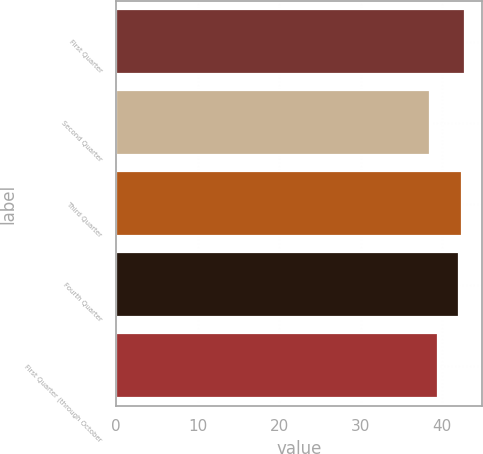Convert chart. <chart><loc_0><loc_0><loc_500><loc_500><bar_chart><fcel>First Quarter<fcel>Second Quarter<fcel>Third Quarter<fcel>Fourth Quarter<fcel>First Quarter (through October<nl><fcel>42.78<fcel>38.44<fcel>42.39<fcel>42<fcel>39.52<nl></chart> 